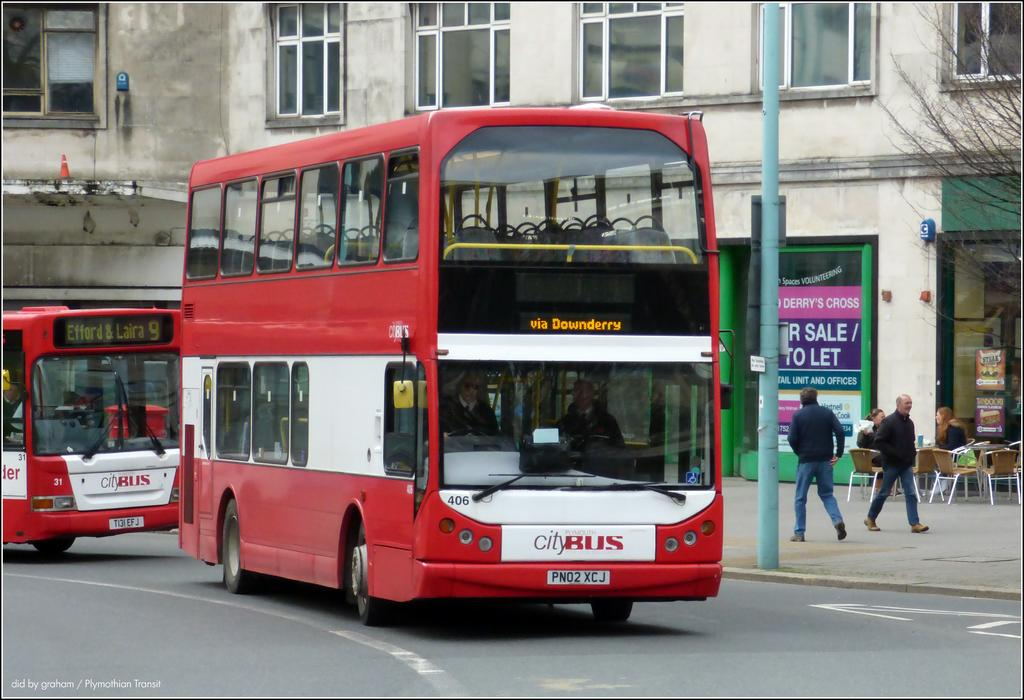Provide a one-sentence caption for the provided image. A red, double decker City Bus travels along via Downderry. 